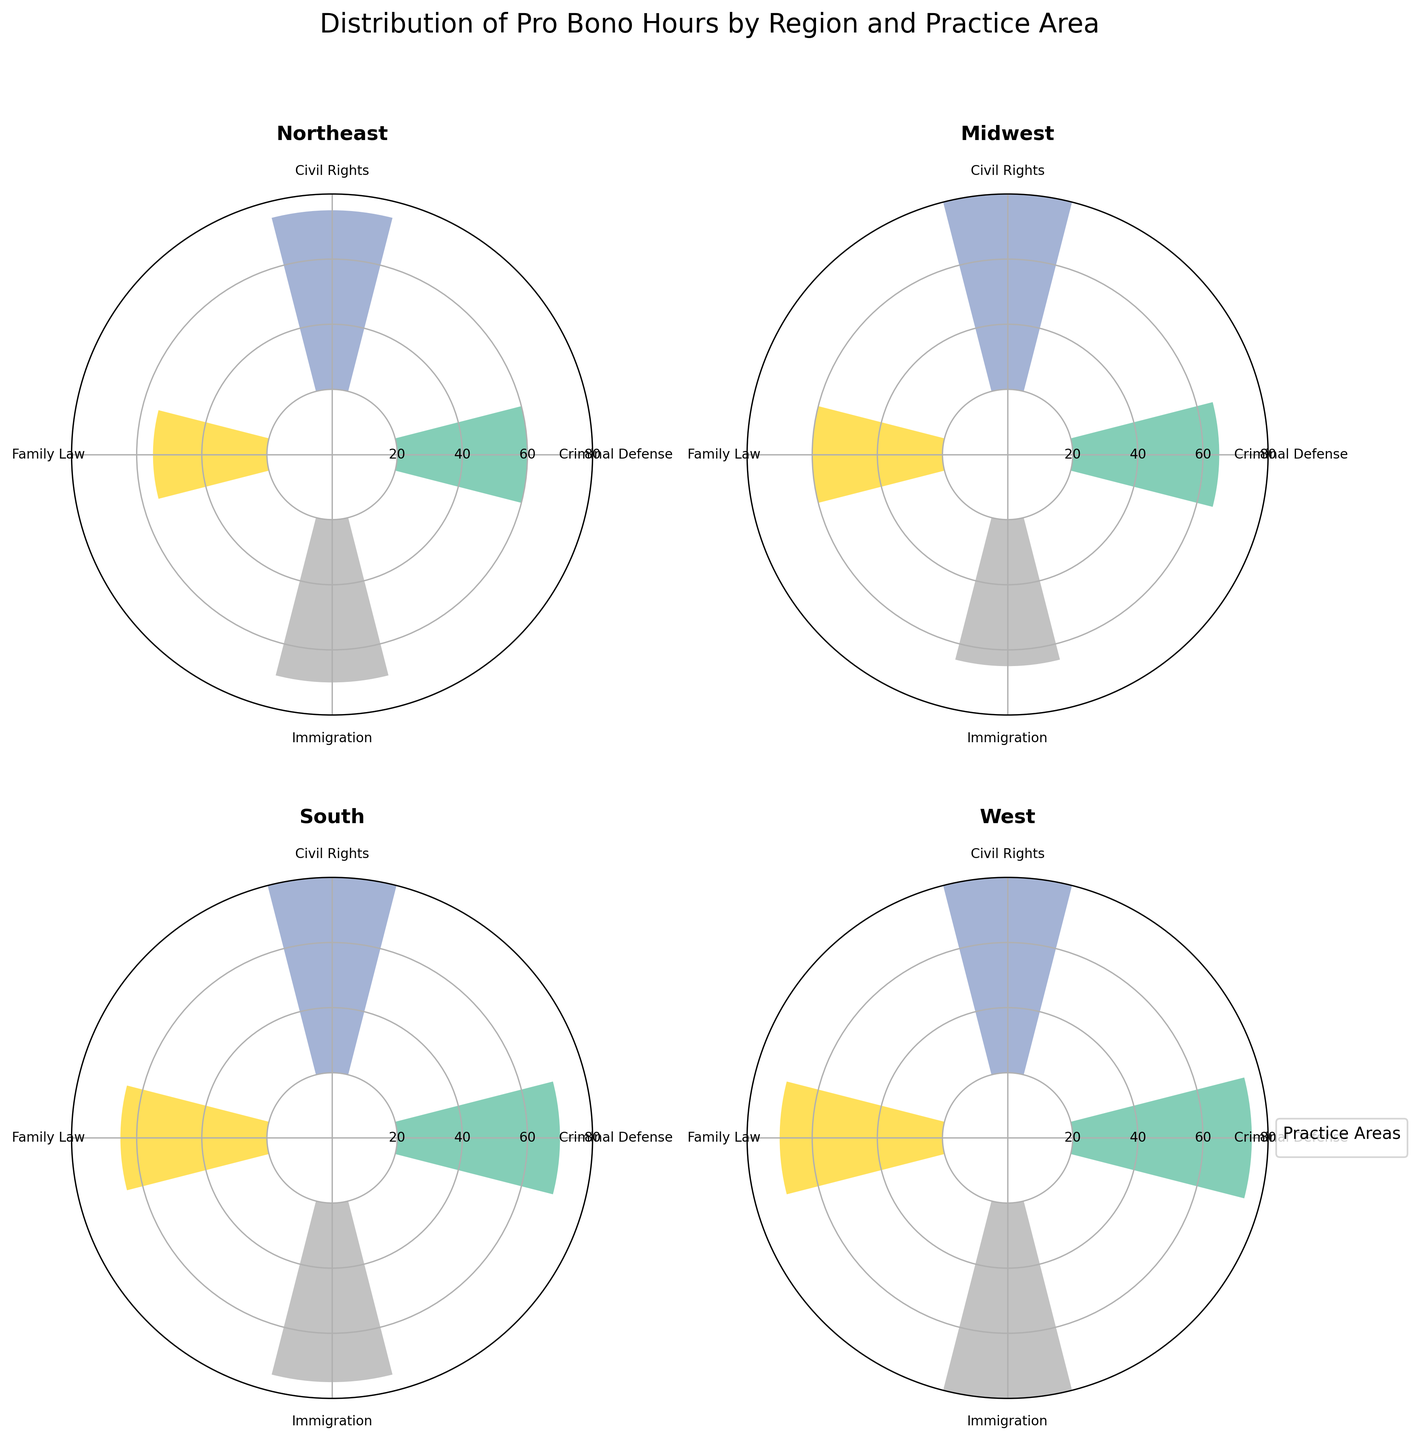How many regions are displayed in the figure? The figure's title mentions "Distribution of Pro Bono Hours by Region and Practice Area," and it contains four separate subplots. Each subplot is titled with a different region: Northeast, Midwest, South, and West.
Answer: 4 What is the practice area with the highest pro bono hours in the West region? In the West region subplot, the highest bar reaches 70 pro bono hours, which corresponds to the Civil Rights practice area based on the legend.
Answer: Civil Rights How do the pro bono hours for Immigration compare across the Northeast and the South regions? In the Northeast region subplot, Immigration is at 50 pro bono hours. In the South region subplot, Immigration is at 55 pro bono hours. Therefore, pro bono hours for Immigration are higher in the South region compared to the Northeast.
Answer: Higher in the South What is the average number of pro bono hours contributed across all practice areas in the Midwest region? To find the average, add the pro bono hours for all practice areas in the Midwest region: 45 (Criminal Defense) + 60 (Civil Rights) + 40 (Family Law) + 45 (Immigration) = 190. Then, divide by the number of practice areas: 190 / 4 = 47.5.
Answer: 47.5 Which region has the lowest number of pro bono hours in Family Law? The subplots show the pro bono hours for Family Law as follows: Northeast (35), Midwest (40), South (45), and West (50). The region with the lowest number is Northeast with 35 pro bono hours.
Answer: Northeast By how much do pro bono hours for Civil Rights differ between the Northeast and the West regions? The pro bono hours for Civil Rights are 55 in the Northeast and 70 in the West. The difference is calculated as 70 - 55 = 15 hours.
Answer: 15 hours Which practice area has the most consistent pro bono hours across all regions? Criminal Defense has the following pro bono hours: Northeast (40), Midwest (45), South (50), and West (55). These values increase consistently by 5 across each region.
Answer: Criminal Defense How does the distribution of pro bono hours in the South region compare to the distribution in the Northeast region? In both regions, Civil Rights has the highest pro bono hours (Northeast: 55, South: 65), Family Law has the lowest (Northeast: 35, South: 45). Other practice areas in the South (Criminal Defense: 50, Immigration: 55) are higher compared to those in the Northeast (Criminal Defense: 40, Immigration: 50). Generally, pro bono hours are higher in the South compared to the Northeast for each practice area.
Answer: Higher in the South 